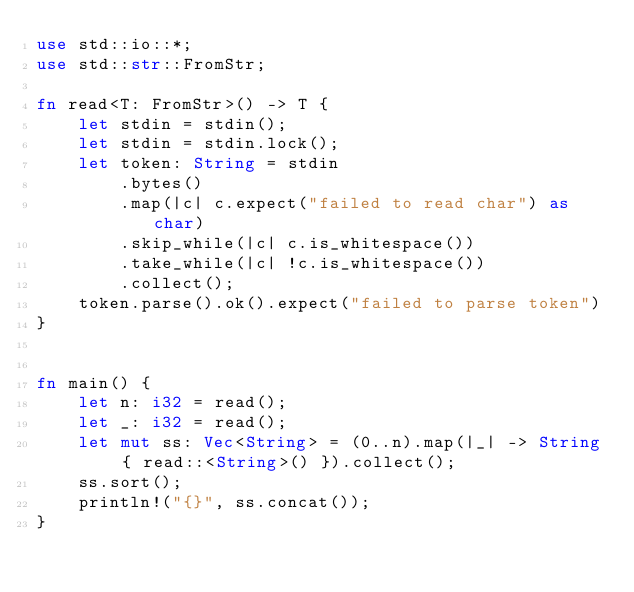<code> <loc_0><loc_0><loc_500><loc_500><_Rust_>use std::io::*;
use std::str::FromStr;

fn read<T: FromStr>() -> T {
    let stdin = stdin();
    let stdin = stdin.lock();
    let token: String = stdin
        .bytes()
        .map(|c| c.expect("failed to read char") as char) 
        .skip_while(|c| c.is_whitespace())
        .take_while(|c| !c.is_whitespace())
        .collect();
    token.parse().ok().expect("failed to parse token")
}


fn main() {
    let n: i32 = read();
    let _: i32 = read();
    let mut ss: Vec<String> = (0..n).map(|_| -> String { read::<String>() }).collect();
    ss.sort();
    println!("{}", ss.concat());
}
</code> 